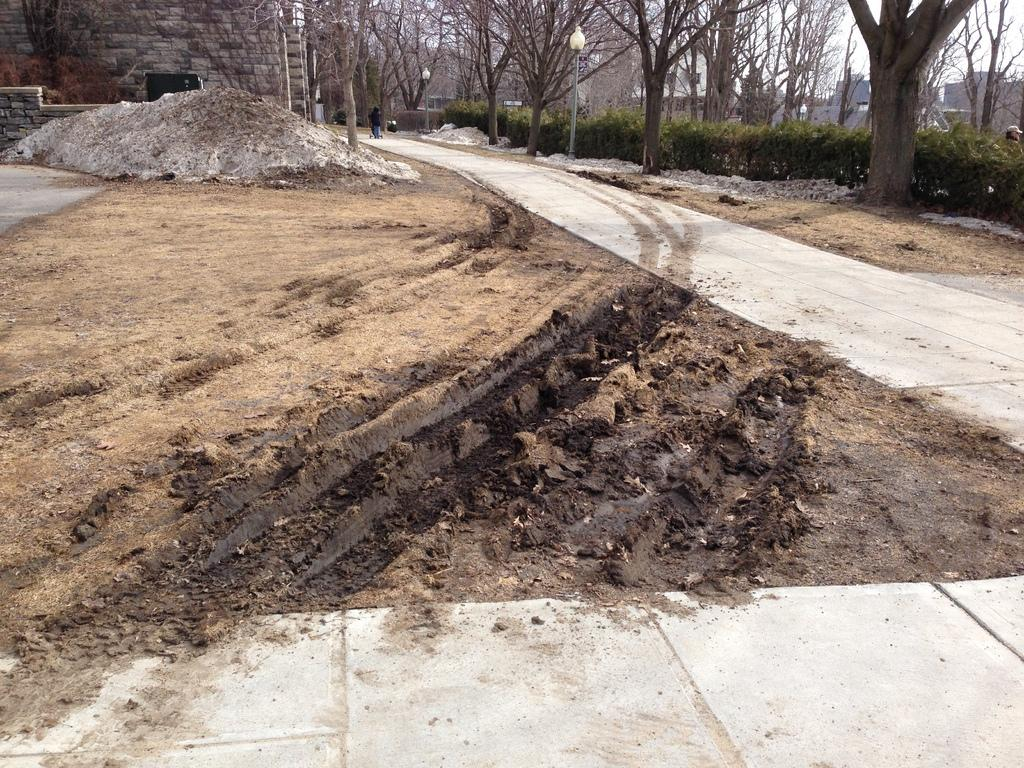What type of pathway is visible in the image? There is a road in the image. What structure can be seen in the image? There is a wall in the image. What type of terrain is present in the image? There is mud in the image. What type of illumination is present in the image? There are lights on poles in the image. What type of vegetation is present in the image? There are plants and trees in the image. What type of background can be seen in the image? There are buildings and sky visible in the background of the image. What type of plot is being discussed in the meeting in the image? There is no meeting present in the image, so it is not possible to determine what type of plot is being discussed. 